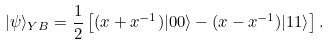<formula> <loc_0><loc_0><loc_500><loc_500>| \psi \rangle _ { Y B } = \frac { 1 } { 2 } \left [ ( x + x ^ { - 1 } ) | 0 0 \rangle - ( x - x ^ { - 1 } ) | 1 1 \rangle \right ] .</formula> 